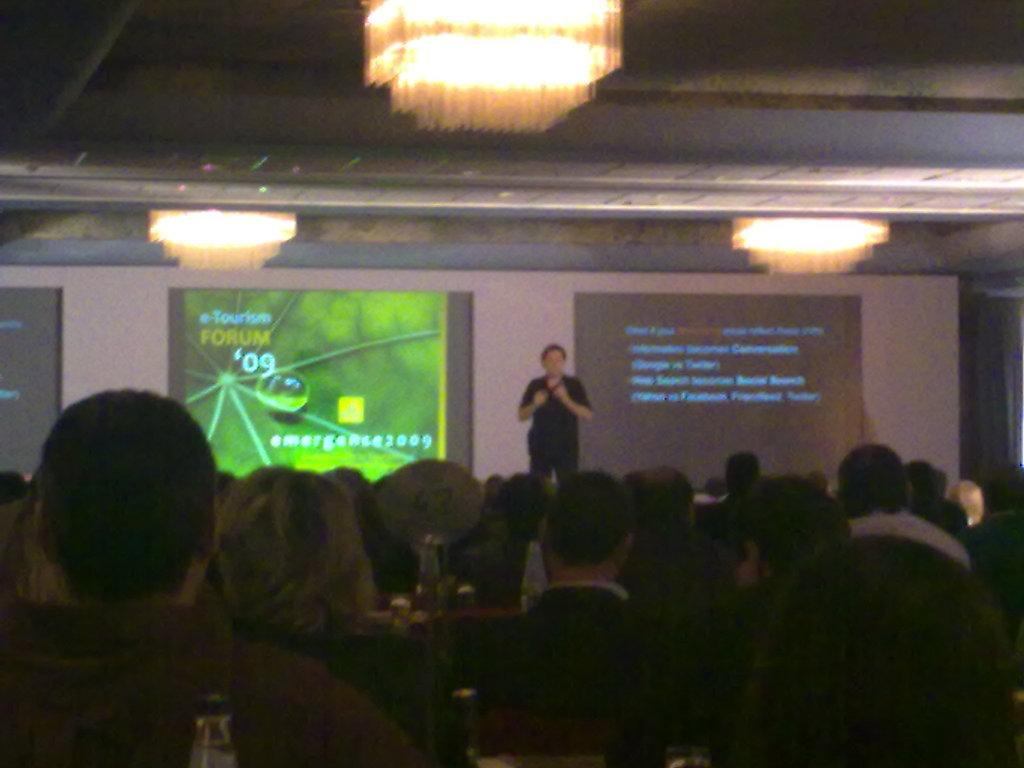What is happening in the foreground of the image? There is a group of people sitting in the foreground. What can be seen on the table in the image? There is a bottle and a board on the table. What is visible in the background of the image? In the background, there is a person standing, multiple screens, and chandeliers. What time of day is it during the journey along the coast in the image? There is no journey along the coast in the image, nor is there any indication of the time of day. 